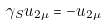<formula> <loc_0><loc_0><loc_500><loc_500>\gamma _ { S } u _ { 2 \mu } = - u _ { 2 \mu }</formula> 